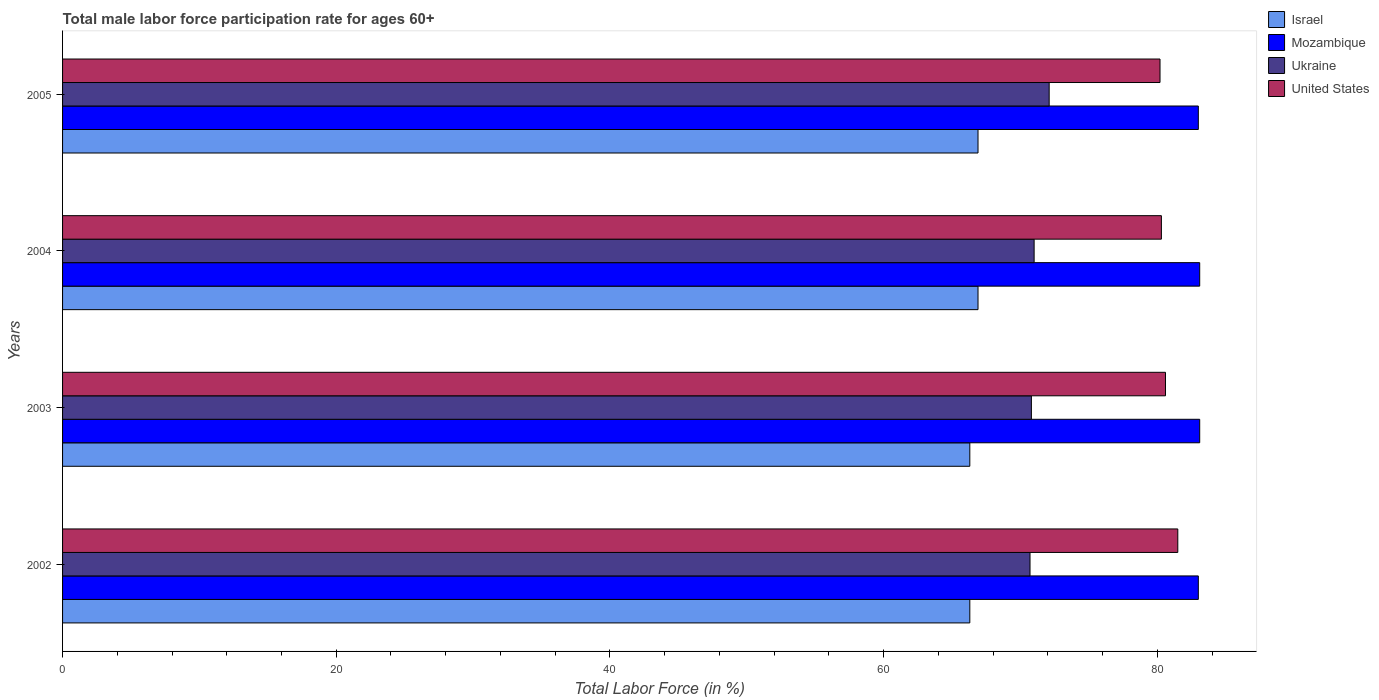How many groups of bars are there?
Your answer should be compact. 4. How many bars are there on the 1st tick from the bottom?
Give a very brief answer. 4. What is the label of the 4th group of bars from the top?
Your answer should be very brief. 2002. What is the male labor force participation rate in United States in 2002?
Ensure brevity in your answer.  81.5. Across all years, what is the maximum male labor force participation rate in Israel?
Provide a short and direct response. 66.9. Across all years, what is the minimum male labor force participation rate in Mozambique?
Keep it short and to the point. 83. In which year was the male labor force participation rate in Israel maximum?
Provide a succinct answer. 2004. What is the total male labor force participation rate in Ukraine in the graph?
Provide a succinct answer. 284.6. What is the difference between the male labor force participation rate in Ukraine in 2002 and that in 2004?
Your response must be concise. -0.3. What is the difference between the male labor force participation rate in Mozambique in 2004 and the male labor force participation rate in Israel in 2003?
Keep it short and to the point. 16.8. What is the average male labor force participation rate in Mozambique per year?
Give a very brief answer. 83.05. In the year 2004, what is the difference between the male labor force participation rate in Mozambique and male labor force participation rate in Israel?
Ensure brevity in your answer.  16.2. What is the ratio of the male labor force participation rate in United States in 2002 to that in 2003?
Provide a succinct answer. 1.01. Is the male labor force participation rate in Israel in 2003 less than that in 2005?
Provide a short and direct response. Yes. What is the difference between the highest and the second highest male labor force participation rate in United States?
Keep it short and to the point. 0.9. What is the difference between the highest and the lowest male labor force participation rate in United States?
Make the answer very short. 1.3. In how many years, is the male labor force participation rate in Ukraine greater than the average male labor force participation rate in Ukraine taken over all years?
Provide a short and direct response. 1. Is the sum of the male labor force participation rate in Israel in 2002 and 2004 greater than the maximum male labor force participation rate in Ukraine across all years?
Offer a very short reply. Yes. Is it the case that in every year, the sum of the male labor force participation rate in United States and male labor force participation rate in Israel is greater than the sum of male labor force participation rate in Ukraine and male labor force participation rate in Mozambique?
Provide a succinct answer. Yes. What does the 3rd bar from the top in 2003 represents?
Your response must be concise. Mozambique. Is it the case that in every year, the sum of the male labor force participation rate in Israel and male labor force participation rate in United States is greater than the male labor force participation rate in Mozambique?
Your answer should be very brief. Yes. How many bars are there?
Offer a terse response. 16. Are all the bars in the graph horizontal?
Offer a terse response. Yes. How many years are there in the graph?
Offer a terse response. 4. Are the values on the major ticks of X-axis written in scientific E-notation?
Your answer should be compact. No. Does the graph contain any zero values?
Offer a very short reply. No. Does the graph contain grids?
Give a very brief answer. No. Where does the legend appear in the graph?
Ensure brevity in your answer.  Top right. How many legend labels are there?
Offer a terse response. 4. What is the title of the graph?
Your answer should be very brief. Total male labor force participation rate for ages 60+. What is the label or title of the X-axis?
Offer a terse response. Total Labor Force (in %). What is the label or title of the Y-axis?
Your response must be concise. Years. What is the Total Labor Force (in %) in Israel in 2002?
Ensure brevity in your answer.  66.3. What is the Total Labor Force (in %) of Ukraine in 2002?
Ensure brevity in your answer.  70.7. What is the Total Labor Force (in %) in United States in 2002?
Ensure brevity in your answer.  81.5. What is the Total Labor Force (in %) in Israel in 2003?
Your answer should be very brief. 66.3. What is the Total Labor Force (in %) in Mozambique in 2003?
Give a very brief answer. 83.1. What is the Total Labor Force (in %) in Ukraine in 2003?
Offer a very short reply. 70.8. What is the Total Labor Force (in %) in United States in 2003?
Provide a succinct answer. 80.6. What is the Total Labor Force (in %) in Israel in 2004?
Provide a short and direct response. 66.9. What is the Total Labor Force (in %) of Mozambique in 2004?
Ensure brevity in your answer.  83.1. What is the Total Labor Force (in %) of Ukraine in 2004?
Ensure brevity in your answer.  71. What is the Total Labor Force (in %) in United States in 2004?
Give a very brief answer. 80.3. What is the Total Labor Force (in %) in Israel in 2005?
Ensure brevity in your answer.  66.9. What is the Total Labor Force (in %) in Mozambique in 2005?
Provide a short and direct response. 83. What is the Total Labor Force (in %) of Ukraine in 2005?
Make the answer very short. 72.1. What is the Total Labor Force (in %) of United States in 2005?
Your answer should be compact. 80.2. Across all years, what is the maximum Total Labor Force (in %) of Israel?
Provide a succinct answer. 66.9. Across all years, what is the maximum Total Labor Force (in %) of Mozambique?
Offer a very short reply. 83.1. Across all years, what is the maximum Total Labor Force (in %) of Ukraine?
Make the answer very short. 72.1. Across all years, what is the maximum Total Labor Force (in %) of United States?
Make the answer very short. 81.5. Across all years, what is the minimum Total Labor Force (in %) of Israel?
Provide a short and direct response. 66.3. Across all years, what is the minimum Total Labor Force (in %) in Ukraine?
Keep it short and to the point. 70.7. Across all years, what is the minimum Total Labor Force (in %) in United States?
Ensure brevity in your answer.  80.2. What is the total Total Labor Force (in %) in Israel in the graph?
Offer a terse response. 266.4. What is the total Total Labor Force (in %) in Mozambique in the graph?
Offer a terse response. 332.2. What is the total Total Labor Force (in %) of Ukraine in the graph?
Provide a succinct answer. 284.6. What is the total Total Labor Force (in %) in United States in the graph?
Ensure brevity in your answer.  322.6. What is the difference between the Total Labor Force (in %) in Israel in 2002 and that in 2003?
Provide a short and direct response. 0. What is the difference between the Total Labor Force (in %) of Ukraine in 2002 and that in 2003?
Provide a short and direct response. -0.1. What is the difference between the Total Labor Force (in %) of United States in 2002 and that in 2003?
Provide a short and direct response. 0.9. What is the difference between the Total Labor Force (in %) of Mozambique in 2002 and that in 2004?
Keep it short and to the point. -0.1. What is the difference between the Total Labor Force (in %) of Ukraine in 2002 and that in 2004?
Offer a very short reply. -0.3. What is the difference between the Total Labor Force (in %) in Ukraine in 2002 and that in 2005?
Your answer should be very brief. -1.4. What is the difference between the Total Labor Force (in %) of Ukraine in 2003 and that in 2004?
Provide a succinct answer. -0.2. What is the difference between the Total Labor Force (in %) of Mozambique in 2003 and that in 2005?
Offer a very short reply. 0.1. What is the difference between the Total Labor Force (in %) in Ukraine in 2003 and that in 2005?
Your response must be concise. -1.3. What is the difference between the Total Labor Force (in %) of United States in 2003 and that in 2005?
Offer a very short reply. 0.4. What is the difference between the Total Labor Force (in %) of United States in 2004 and that in 2005?
Offer a terse response. 0.1. What is the difference between the Total Labor Force (in %) in Israel in 2002 and the Total Labor Force (in %) in Mozambique in 2003?
Your response must be concise. -16.8. What is the difference between the Total Labor Force (in %) of Israel in 2002 and the Total Labor Force (in %) of United States in 2003?
Give a very brief answer. -14.3. What is the difference between the Total Labor Force (in %) in Mozambique in 2002 and the Total Labor Force (in %) in Ukraine in 2003?
Give a very brief answer. 12.2. What is the difference between the Total Labor Force (in %) in Israel in 2002 and the Total Labor Force (in %) in Mozambique in 2004?
Your answer should be very brief. -16.8. What is the difference between the Total Labor Force (in %) of Israel in 2002 and the Total Labor Force (in %) of United States in 2004?
Offer a terse response. -14. What is the difference between the Total Labor Force (in %) in Mozambique in 2002 and the Total Labor Force (in %) in United States in 2004?
Give a very brief answer. 2.7. What is the difference between the Total Labor Force (in %) in Israel in 2002 and the Total Labor Force (in %) in Mozambique in 2005?
Your answer should be very brief. -16.7. What is the difference between the Total Labor Force (in %) of Israel in 2002 and the Total Labor Force (in %) of United States in 2005?
Your response must be concise. -13.9. What is the difference between the Total Labor Force (in %) in Mozambique in 2002 and the Total Labor Force (in %) in Ukraine in 2005?
Make the answer very short. 10.9. What is the difference between the Total Labor Force (in %) of Mozambique in 2002 and the Total Labor Force (in %) of United States in 2005?
Your response must be concise. 2.8. What is the difference between the Total Labor Force (in %) in Israel in 2003 and the Total Labor Force (in %) in Mozambique in 2004?
Your answer should be compact. -16.8. What is the difference between the Total Labor Force (in %) of Mozambique in 2003 and the Total Labor Force (in %) of Ukraine in 2004?
Make the answer very short. 12.1. What is the difference between the Total Labor Force (in %) of Israel in 2003 and the Total Labor Force (in %) of Mozambique in 2005?
Ensure brevity in your answer.  -16.7. What is the difference between the Total Labor Force (in %) of Israel in 2003 and the Total Labor Force (in %) of Ukraine in 2005?
Provide a succinct answer. -5.8. What is the difference between the Total Labor Force (in %) of Israel in 2003 and the Total Labor Force (in %) of United States in 2005?
Provide a succinct answer. -13.9. What is the difference between the Total Labor Force (in %) of Mozambique in 2003 and the Total Labor Force (in %) of Ukraine in 2005?
Your response must be concise. 11. What is the difference between the Total Labor Force (in %) of Mozambique in 2003 and the Total Labor Force (in %) of United States in 2005?
Keep it short and to the point. 2.9. What is the difference between the Total Labor Force (in %) in Ukraine in 2003 and the Total Labor Force (in %) in United States in 2005?
Offer a very short reply. -9.4. What is the difference between the Total Labor Force (in %) in Israel in 2004 and the Total Labor Force (in %) in Mozambique in 2005?
Offer a very short reply. -16.1. What is the difference between the Total Labor Force (in %) of Israel in 2004 and the Total Labor Force (in %) of Ukraine in 2005?
Make the answer very short. -5.2. What is the difference between the Total Labor Force (in %) of Mozambique in 2004 and the Total Labor Force (in %) of Ukraine in 2005?
Provide a short and direct response. 11. What is the difference between the Total Labor Force (in %) in Mozambique in 2004 and the Total Labor Force (in %) in United States in 2005?
Ensure brevity in your answer.  2.9. What is the average Total Labor Force (in %) of Israel per year?
Offer a terse response. 66.6. What is the average Total Labor Force (in %) in Mozambique per year?
Your answer should be very brief. 83.05. What is the average Total Labor Force (in %) in Ukraine per year?
Your answer should be very brief. 71.15. What is the average Total Labor Force (in %) in United States per year?
Offer a terse response. 80.65. In the year 2002, what is the difference between the Total Labor Force (in %) of Israel and Total Labor Force (in %) of Mozambique?
Your response must be concise. -16.7. In the year 2002, what is the difference between the Total Labor Force (in %) in Israel and Total Labor Force (in %) in Ukraine?
Provide a succinct answer. -4.4. In the year 2002, what is the difference between the Total Labor Force (in %) in Israel and Total Labor Force (in %) in United States?
Make the answer very short. -15.2. In the year 2002, what is the difference between the Total Labor Force (in %) of Mozambique and Total Labor Force (in %) of Ukraine?
Your answer should be compact. 12.3. In the year 2003, what is the difference between the Total Labor Force (in %) of Israel and Total Labor Force (in %) of Mozambique?
Give a very brief answer. -16.8. In the year 2003, what is the difference between the Total Labor Force (in %) of Israel and Total Labor Force (in %) of United States?
Give a very brief answer. -14.3. In the year 2003, what is the difference between the Total Labor Force (in %) of Mozambique and Total Labor Force (in %) of Ukraine?
Provide a short and direct response. 12.3. In the year 2003, what is the difference between the Total Labor Force (in %) in Mozambique and Total Labor Force (in %) in United States?
Keep it short and to the point. 2.5. In the year 2003, what is the difference between the Total Labor Force (in %) in Ukraine and Total Labor Force (in %) in United States?
Offer a terse response. -9.8. In the year 2004, what is the difference between the Total Labor Force (in %) in Israel and Total Labor Force (in %) in Mozambique?
Your answer should be compact. -16.2. In the year 2004, what is the difference between the Total Labor Force (in %) in Israel and Total Labor Force (in %) in Ukraine?
Offer a terse response. -4.1. In the year 2004, what is the difference between the Total Labor Force (in %) of Ukraine and Total Labor Force (in %) of United States?
Provide a short and direct response. -9.3. In the year 2005, what is the difference between the Total Labor Force (in %) of Israel and Total Labor Force (in %) of Mozambique?
Offer a terse response. -16.1. In the year 2005, what is the difference between the Total Labor Force (in %) in Israel and Total Labor Force (in %) in United States?
Ensure brevity in your answer.  -13.3. What is the ratio of the Total Labor Force (in %) of Israel in 2002 to that in 2003?
Ensure brevity in your answer.  1. What is the ratio of the Total Labor Force (in %) of Mozambique in 2002 to that in 2003?
Provide a short and direct response. 1. What is the ratio of the Total Labor Force (in %) in Ukraine in 2002 to that in 2003?
Offer a terse response. 1. What is the ratio of the Total Labor Force (in %) in United States in 2002 to that in 2003?
Your answer should be very brief. 1.01. What is the ratio of the Total Labor Force (in %) in Mozambique in 2002 to that in 2004?
Provide a succinct answer. 1. What is the ratio of the Total Labor Force (in %) in Ukraine in 2002 to that in 2004?
Provide a succinct answer. 1. What is the ratio of the Total Labor Force (in %) in United States in 2002 to that in 2004?
Make the answer very short. 1.01. What is the ratio of the Total Labor Force (in %) in Ukraine in 2002 to that in 2005?
Provide a short and direct response. 0.98. What is the ratio of the Total Labor Force (in %) in United States in 2002 to that in 2005?
Provide a succinct answer. 1.02. What is the ratio of the Total Labor Force (in %) of Israel in 2003 to that in 2004?
Give a very brief answer. 0.99. What is the ratio of the Total Labor Force (in %) in Mozambique in 2003 to that in 2004?
Offer a terse response. 1. What is the ratio of the Total Labor Force (in %) of Israel in 2003 to that in 2005?
Make the answer very short. 0.99. What is the ratio of the Total Labor Force (in %) of United States in 2003 to that in 2005?
Your answer should be very brief. 1. What is the ratio of the Total Labor Force (in %) in Israel in 2004 to that in 2005?
Provide a succinct answer. 1. What is the ratio of the Total Labor Force (in %) of Mozambique in 2004 to that in 2005?
Provide a succinct answer. 1. What is the ratio of the Total Labor Force (in %) of Ukraine in 2004 to that in 2005?
Make the answer very short. 0.98. What is the ratio of the Total Labor Force (in %) in United States in 2004 to that in 2005?
Provide a short and direct response. 1. What is the difference between the highest and the second highest Total Labor Force (in %) in Ukraine?
Your answer should be very brief. 1.1. 